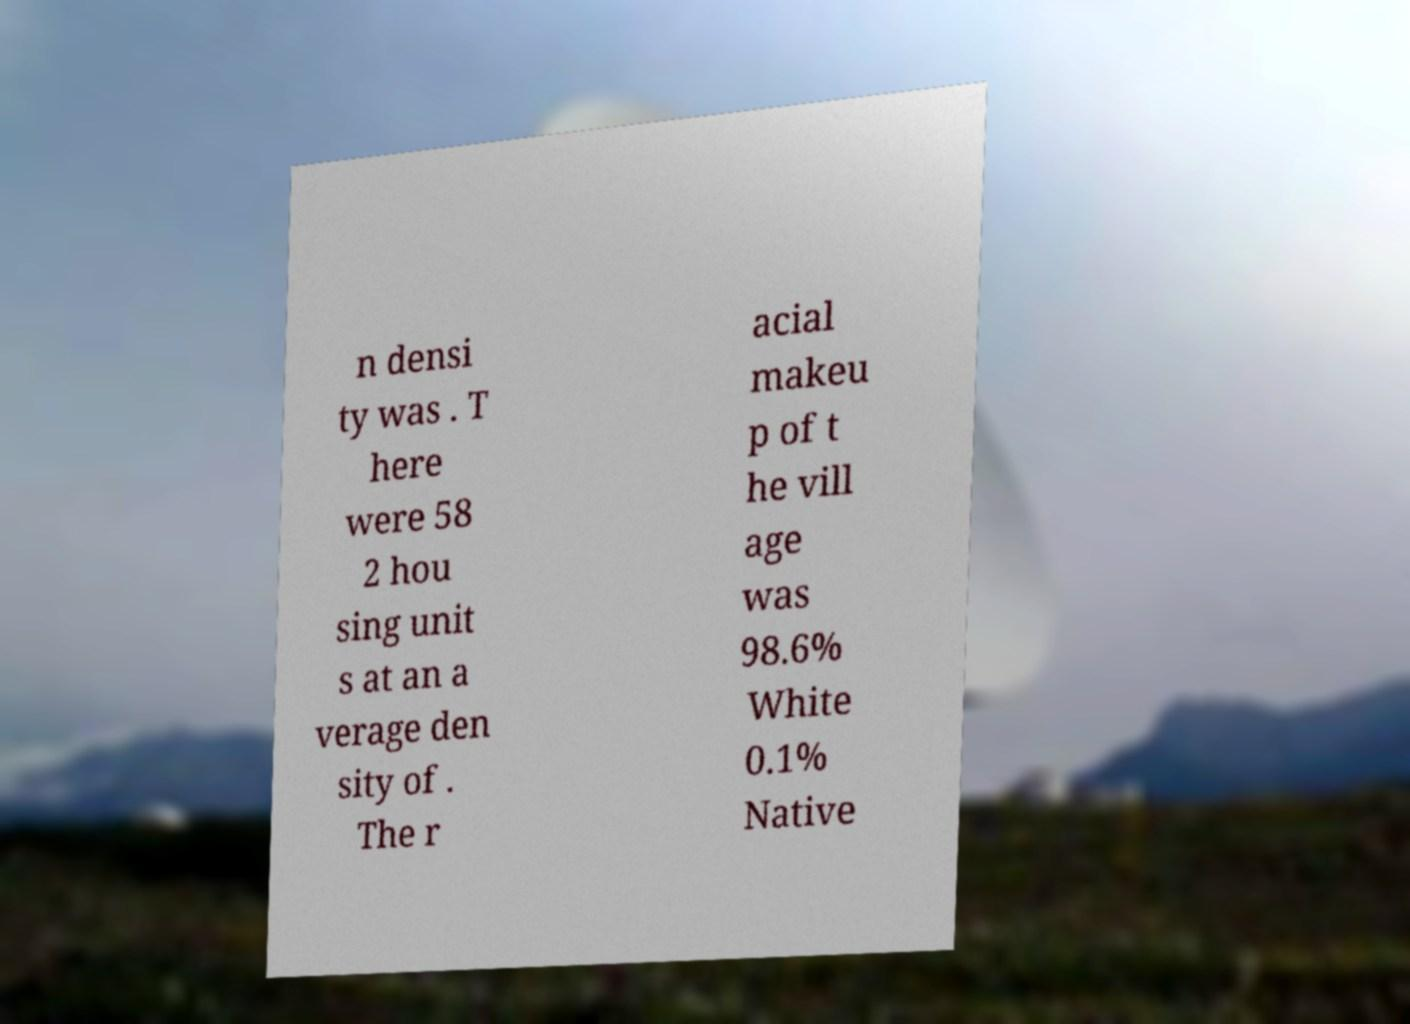I need the written content from this picture converted into text. Can you do that? n densi ty was . T here were 58 2 hou sing unit s at an a verage den sity of . The r acial makeu p of t he vill age was 98.6% White 0.1% Native 